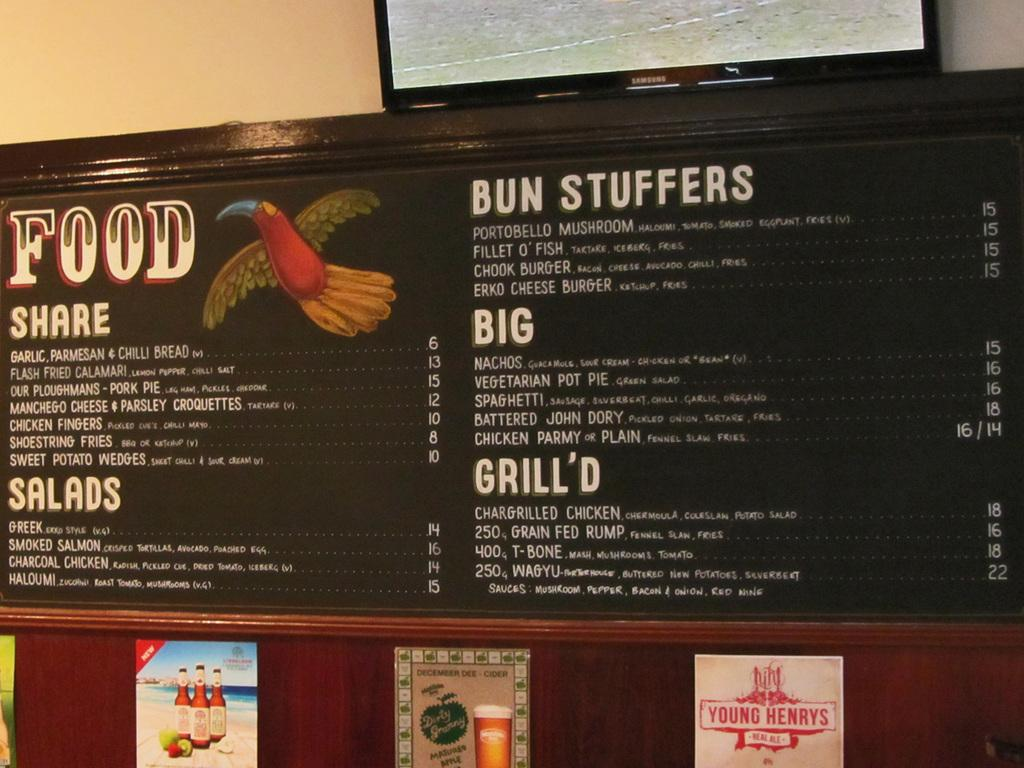<image>
Offer a succinct explanation of the picture presented. A menu shows choices for salads and bun stuffers with big and grilled. 